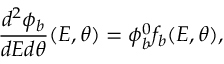Convert formula to latex. <formula><loc_0><loc_0><loc_500><loc_500>\frac { d ^ { 2 } \phi _ { b } } { d E d \theta } ( E , \theta ) = \phi _ { b } ^ { 0 } f _ { b } ( E , \theta ) ,</formula> 